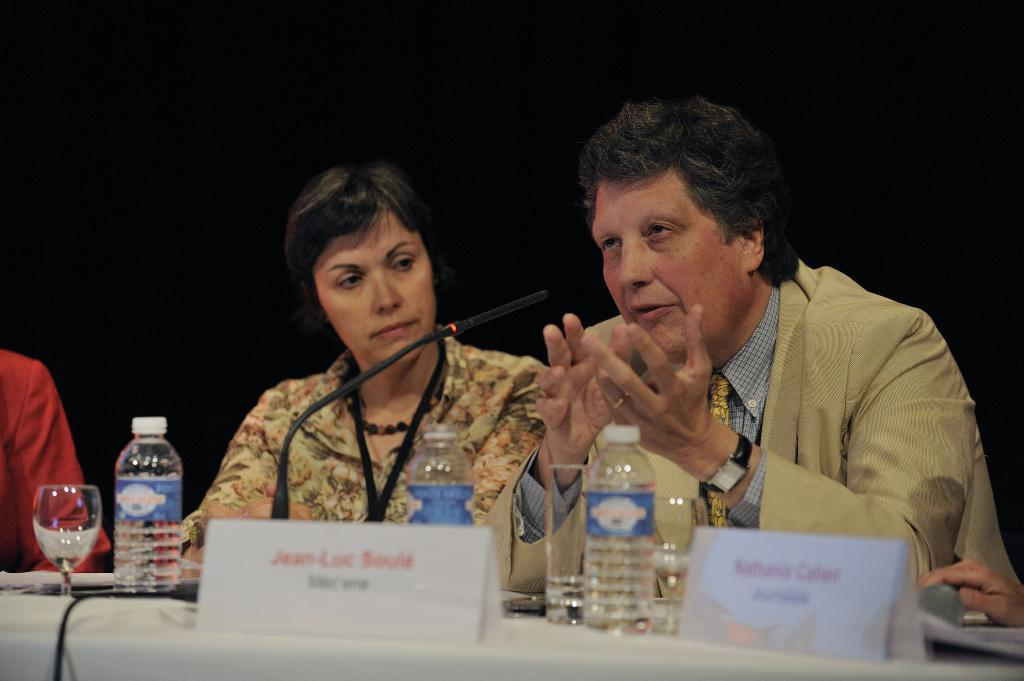What is the main subject in the center of the image? There are people in the center of the image. What is located in front of the people? There is a table in front of the people. What object on the table is used for amplifying sound? A microphone (mic) is present on the table. What items on the table might be used for drinking? There are glasses on the table. What items on the table might be used for pouring drinks? There are bottles on the table. What type of copper material is being used by the laborer in the image? There is no laborer or copper material present in the image. What type of cushion is being used by the people in the image? There is no cushion present in the image. 